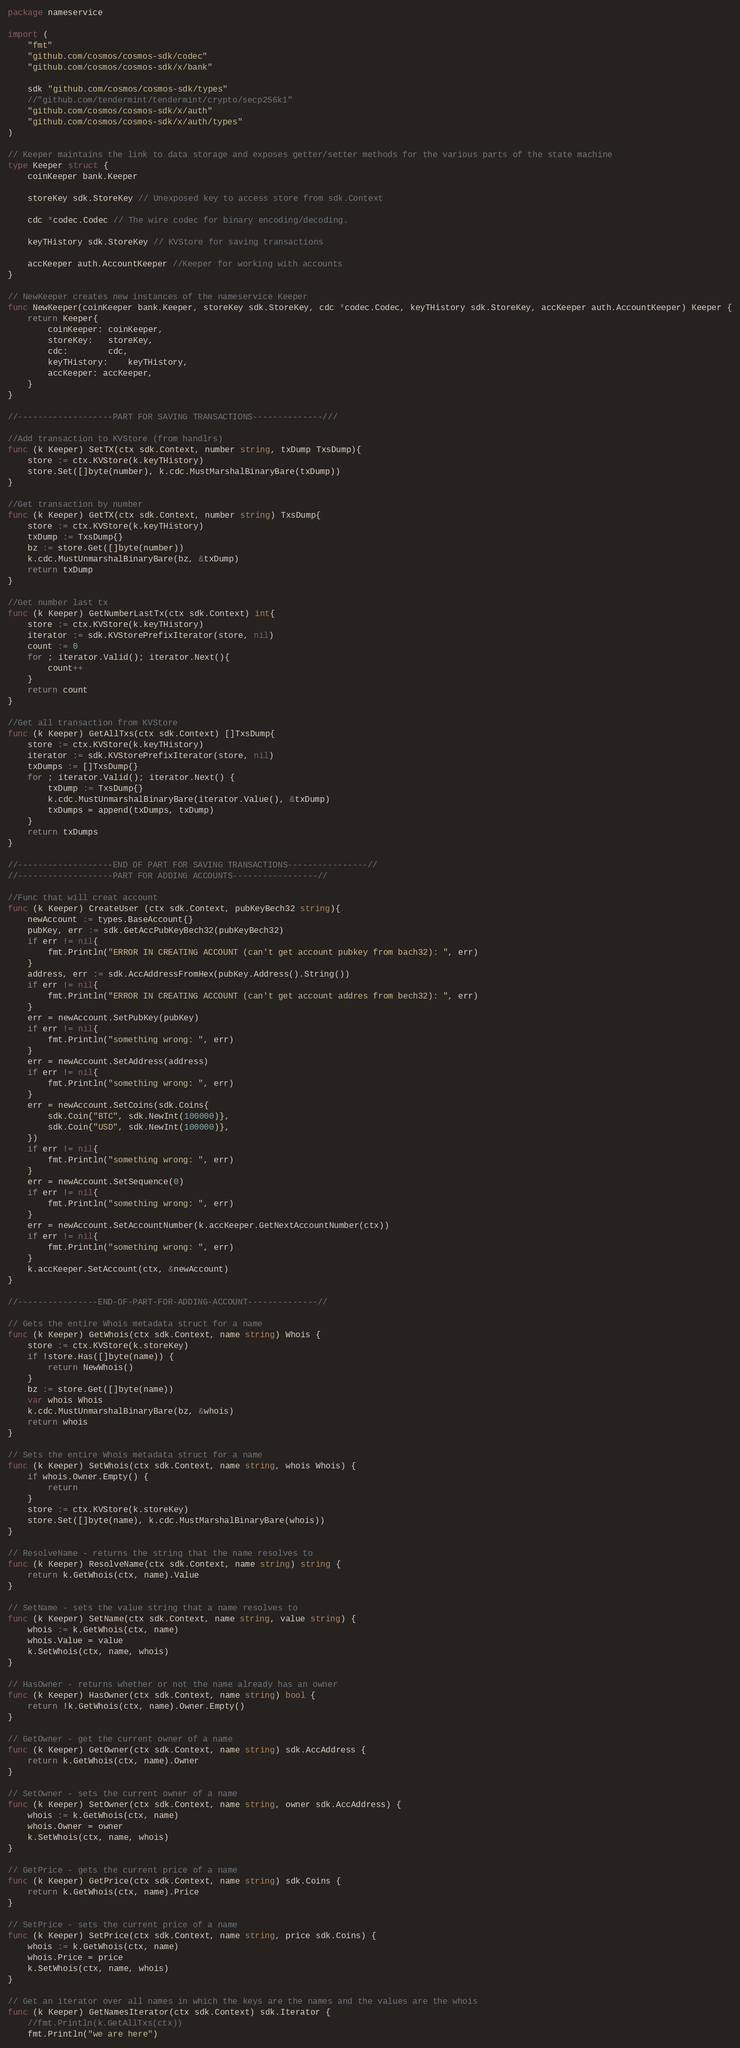<code> <loc_0><loc_0><loc_500><loc_500><_Go_>package nameservice

import (
	"fmt"
	"github.com/cosmos/cosmos-sdk/codec"
	"github.com/cosmos/cosmos-sdk/x/bank"

	sdk "github.com/cosmos/cosmos-sdk/types"
	//"github.com/tendermint/tendermint/crypto/secp256k1"
	"github.com/cosmos/cosmos-sdk/x/auth"
	"github.com/cosmos/cosmos-sdk/x/auth/types"
)

// Keeper maintains the link to data storage and exposes getter/setter methods for the various parts of the state machine
type Keeper struct {
	coinKeeper bank.Keeper

	storeKey sdk.StoreKey // Unexposed key to access store from sdk.Context

	cdc *codec.Codec // The wire codec for binary encoding/decoding.

	keyTHistory sdk.StoreKey // KVStore for saving transactions

	accKeeper auth.AccountKeeper //Keeper for working with accounts
}

// NewKeeper creates new instances of the nameservice Keeper
func NewKeeper(coinKeeper bank.Keeper, storeKey sdk.StoreKey, cdc *codec.Codec, keyTHistory sdk.StoreKey, accKeeper auth.AccountKeeper) Keeper {
	return Keeper{
		coinKeeper: coinKeeper,
		storeKey:   storeKey,
		cdc:        cdc,
		keyTHistory:	keyTHistory,
		accKeeper: accKeeper,
	}
}

//-------------------PART FOR SAVING TRANSACTIONS--------------///

//Add transaction to KVStore (from handlrs)
func (k Keeper) SetTX(ctx sdk.Context, number string, txDump TxsDump){
	store := ctx.KVStore(k.keyTHistory)
	store.Set([]byte(number), k.cdc.MustMarshalBinaryBare(txDump))
}

//Get transaction by number
func (k Keeper) GetTX(ctx sdk.Context, number string) TxsDump{
	store := ctx.KVStore(k.keyTHistory)
	txDump := TxsDump{}
	bz := store.Get([]byte(number))
	k.cdc.MustUnmarshalBinaryBare(bz, &txDump)
	return txDump
}

//Get number last tx
func (k Keeper) GetNumberLastTx(ctx sdk.Context) int{
	store := ctx.KVStore(k.keyTHistory)
	iterator := sdk.KVStorePrefixIterator(store, nil)
	count := 0
	for ; iterator.Valid(); iterator.Next(){
		count++
	}
	return count
}

//Get all transaction from KVStore
func (k Keeper) GetAllTxs(ctx sdk.Context) []TxsDump{
	store := ctx.KVStore(k.keyTHistory)
	iterator := sdk.KVStorePrefixIterator(store, nil)
	txDumps := []TxsDump{}
	for ; iterator.Valid(); iterator.Next() {
		txDump := TxsDump{}
		k.cdc.MustUnmarshalBinaryBare(iterator.Value(), &txDump)
		txDumps = append(txDumps, txDump)
	}
	return txDumps
}

//-------------------END OF PART FOR SAVING TRANSACTIONS----------------//
//-------------------PART FOR ADDING ACCOUNTS-----------------//

//Func that will creat account
func (k Keeper) CreateUser (ctx sdk.Context, pubKeyBech32 string){
	newAccount := types.BaseAccount{}
	pubKey, err := sdk.GetAccPubKeyBech32(pubKeyBech32)
	if err != nil{
		fmt.Println("ERROR IN CREATING ACCOUNT (can't get account pubkey from bach32): ", err)
	}
	address, err := sdk.AccAddressFromHex(pubKey.Address().String())
	if err != nil{
		fmt.Println("ERROR IN CREATING ACCOUNT (can't get account addres from bech32): ", err)
	}
	err = newAccount.SetPubKey(pubKey)
	if err != nil{
		fmt.Println("something wrong: ", err)
	}
	err = newAccount.SetAddress(address)
	if err != nil{
		fmt.Println("something wrong: ", err)
	}
	err = newAccount.SetCoins(sdk.Coins{
		sdk.Coin{"BTC", sdk.NewInt(100000)},
		sdk.Coin{"USD", sdk.NewInt(100000)},
	})
	if err != nil{
		fmt.Println("something wrong: ", err)
	}
	err = newAccount.SetSequence(0)
	if err != nil{
		fmt.Println("something wrong: ", err)
	}
	err = newAccount.SetAccountNumber(k.accKeeper.GetNextAccountNumber(ctx))
	if err != nil{
		fmt.Println("something wrong: ", err)
	}
	k.accKeeper.SetAccount(ctx, &newAccount)
}

//----------------END-OF-PART-FOR-ADDING-ACCOUNT--------------//

// Gets the entire Whois metadata struct for a name
func (k Keeper) GetWhois(ctx sdk.Context, name string) Whois {
	store := ctx.KVStore(k.storeKey)
	if !store.Has([]byte(name)) {
		return NewWhois()
	}
	bz := store.Get([]byte(name))
	var whois Whois
	k.cdc.MustUnmarshalBinaryBare(bz, &whois)
	return whois
}

// Sets the entire Whois metadata struct for a name
func (k Keeper) SetWhois(ctx sdk.Context, name string, whois Whois) {
	if whois.Owner.Empty() {
		return
	}
	store := ctx.KVStore(k.storeKey)
	store.Set([]byte(name), k.cdc.MustMarshalBinaryBare(whois))
}

// ResolveName - returns the string that the name resolves to
func (k Keeper) ResolveName(ctx sdk.Context, name string) string {
	return k.GetWhois(ctx, name).Value
}

// SetName - sets the value string that a name resolves to
func (k Keeper) SetName(ctx sdk.Context, name string, value string) {
	whois := k.GetWhois(ctx, name)
	whois.Value = value
	k.SetWhois(ctx, name, whois)
}

// HasOwner - returns whether or not the name already has an owner
func (k Keeper) HasOwner(ctx sdk.Context, name string) bool {
	return !k.GetWhois(ctx, name).Owner.Empty()
}

// GetOwner - get the current owner of a name
func (k Keeper) GetOwner(ctx sdk.Context, name string) sdk.AccAddress {
	return k.GetWhois(ctx, name).Owner
}

// SetOwner - sets the current owner of a name
func (k Keeper) SetOwner(ctx sdk.Context, name string, owner sdk.AccAddress) {
	whois := k.GetWhois(ctx, name)
	whois.Owner = owner
	k.SetWhois(ctx, name, whois)
}

// GetPrice - gets the current price of a name
func (k Keeper) GetPrice(ctx sdk.Context, name string) sdk.Coins {
	return k.GetWhois(ctx, name).Price
}

// SetPrice - sets the current price of a name
func (k Keeper) SetPrice(ctx sdk.Context, name string, price sdk.Coins) {
	whois := k.GetWhois(ctx, name)
	whois.Price = price
	k.SetWhois(ctx, name, whois)
}

// Get an iterator over all names in which the keys are the names and the values are the whois
func (k Keeper) GetNamesIterator(ctx sdk.Context) sdk.Iterator {
	//fmt.Println(k.GetAllTxs(ctx))
	fmt.Println("we are here")</code> 